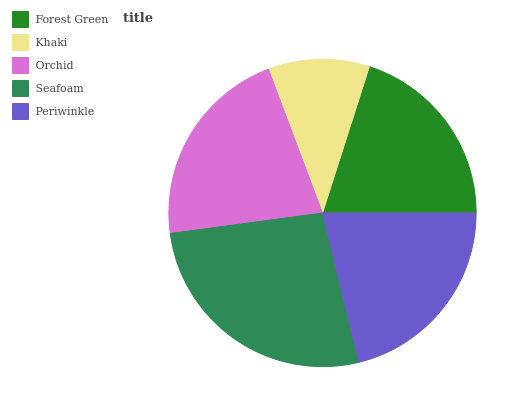Is Khaki the minimum?
Answer yes or no. Yes. Is Seafoam the maximum?
Answer yes or no. Yes. Is Orchid the minimum?
Answer yes or no. No. Is Orchid the maximum?
Answer yes or no. No. Is Orchid greater than Khaki?
Answer yes or no. Yes. Is Khaki less than Orchid?
Answer yes or no. Yes. Is Khaki greater than Orchid?
Answer yes or no. No. Is Orchid less than Khaki?
Answer yes or no. No. Is Periwinkle the high median?
Answer yes or no. Yes. Is Periwinkle the low median?
Answer yes or no. Yes. Is Forest Green the high median?
Answer yes or no. No. Is Forest Green the low median?
Answer yes or no. No. 